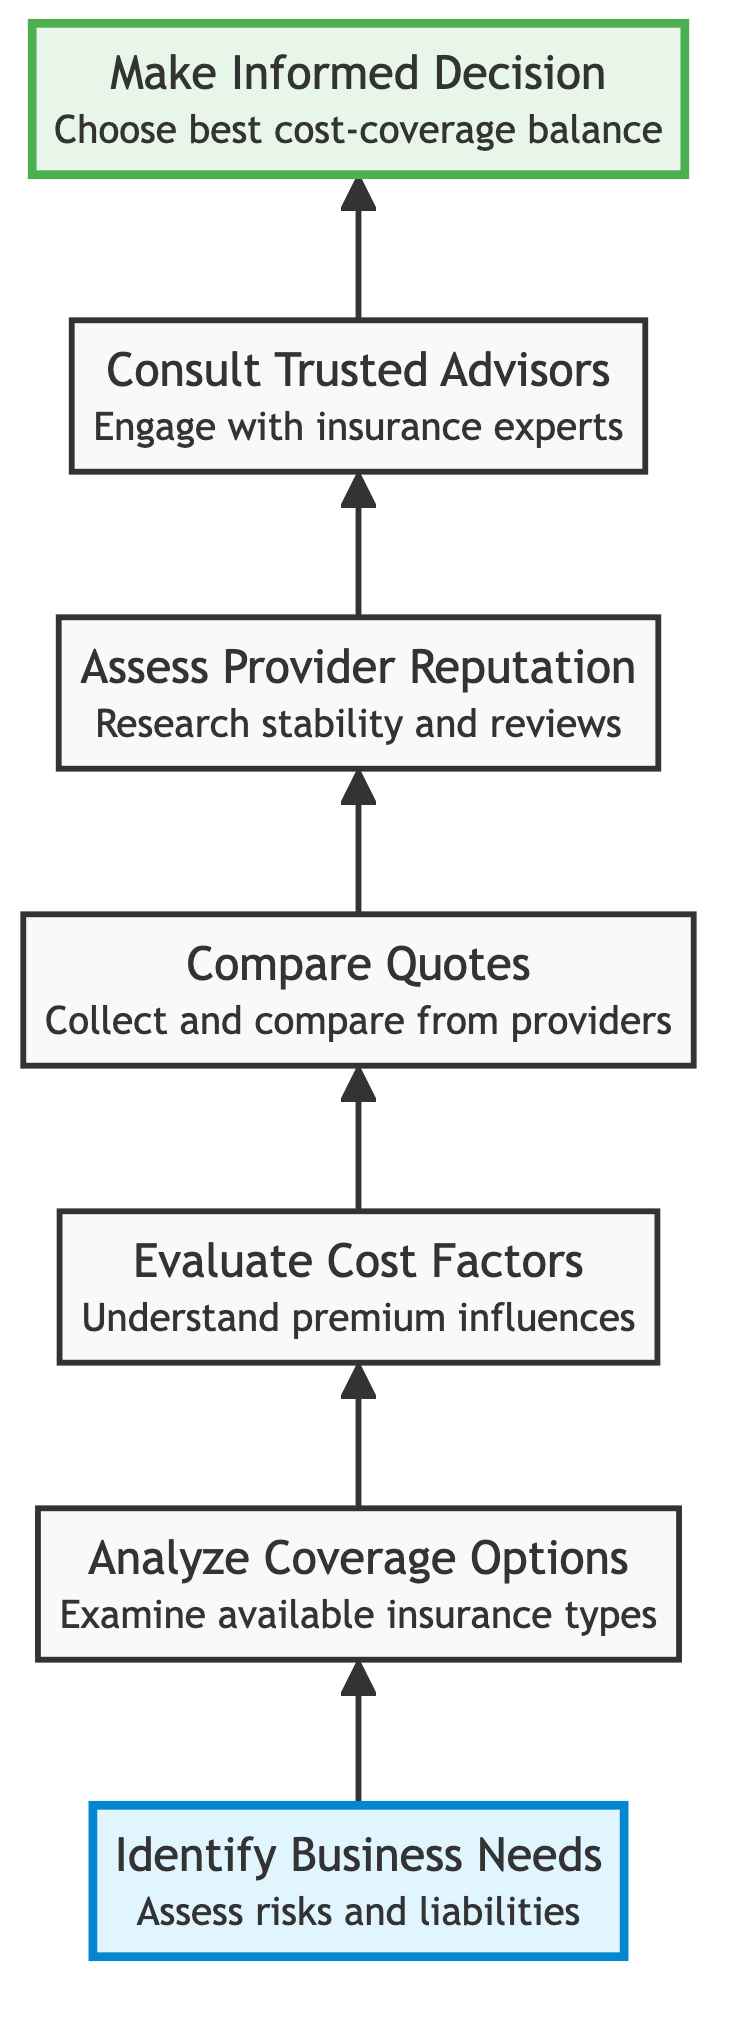What is the first step in the flow chart? The first step in the flow chart is "Identify Business Needs." It is positioned at the bottom of the diagram and serves as the starting point for evaluating insurance options.
Answer: Identify Business Needs How many steps are there in total? There are seven steps in total, starting from "Identify Business Needs" at the bottom and culminating in "Make Informed Decision" at the top. Each step is sequentially connected.
Answer: 7 Which step involves examining insurance types? The step that involves examining insurance types is "Analyze Coverage Options." It is the second step in the flow chart, positioned just above "Identify Business Needs."
Answer: Analyze Coverage Options What do you do after evaluating cost factors? After evaluating cost factors, the next step is to "Compare Quotes." This connects the evaluation of cost with practical options from various providers.
Answer: Compare Quotes Which step focuses on researching the insurance provider's reputation? The step that focuses on researching the insurance provider's reputation is "Assess Provider Reputation." This is the fifth step in the flow chart, located before consulting trusted advisors.
Answer: Assess Provider Reputation What is the last step in the flow chart? The last step in the flow chart is "Make Informed Decision." It sits at the top, indicating the final action based on the previous analyses and consultations.
Answer: Make Informed Decision How does "Consult Trusted Advisors" relate to making an informed decision? "Consult Trusted Advisors" provides personalized advice crucial for understanding the insurance options and negotiating terms, leading to making an informed decision in the subsequent step.
Answer: It aids in decision-making What should be researched for choosing the right insurance provider? For choosing the right insurance provider, one should research their reputation and financial stability. This is emphasized in the step "Assess Provider Reputation."
Answer: Reputation and financial stability 